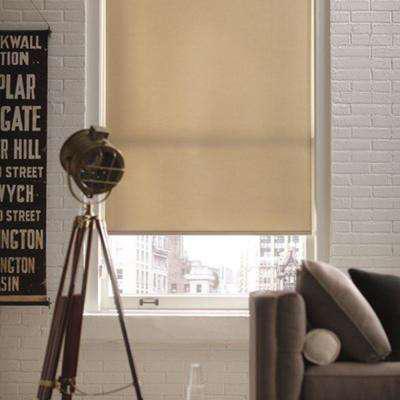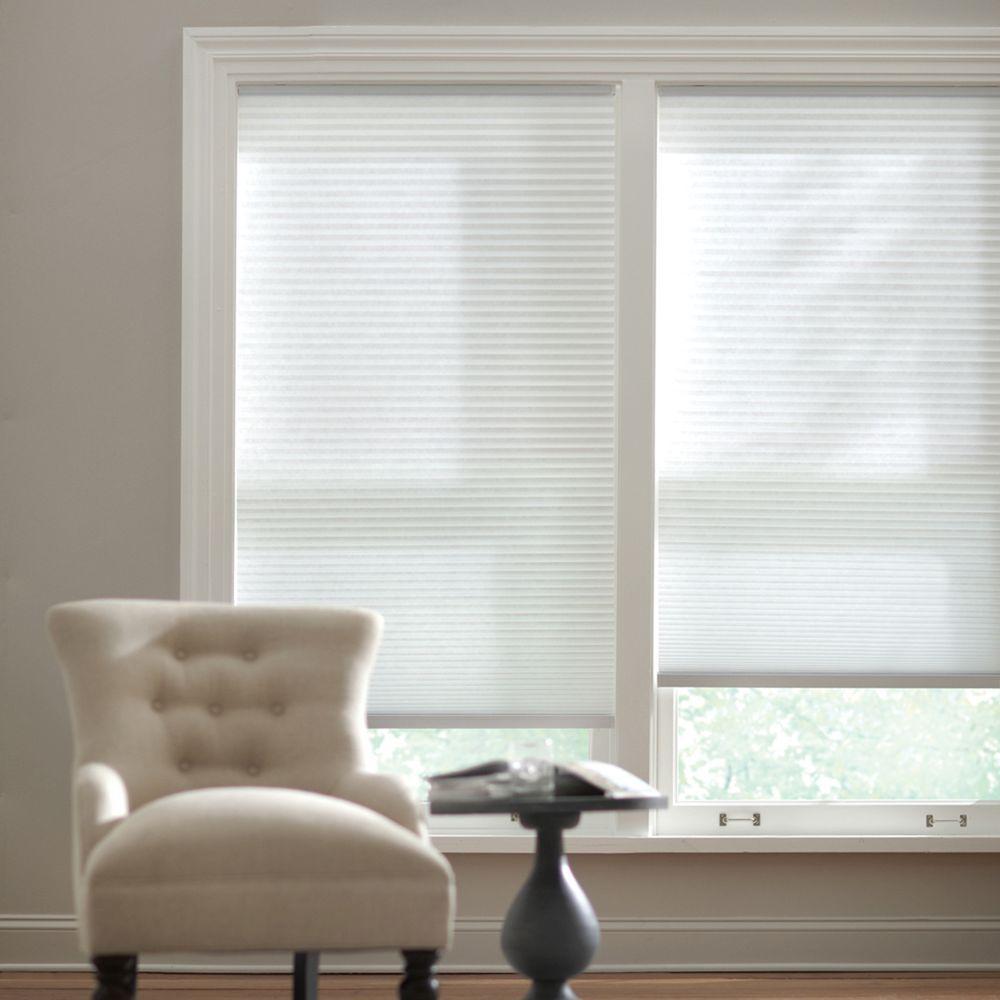The first image is the image on the left, the second image is the image on the right. Considering the images on both sides, is "An image shows a tufted chair on the left in front of side-by-side windows with shades that are not fully closed." valid? Answer yes or no. Yes. 